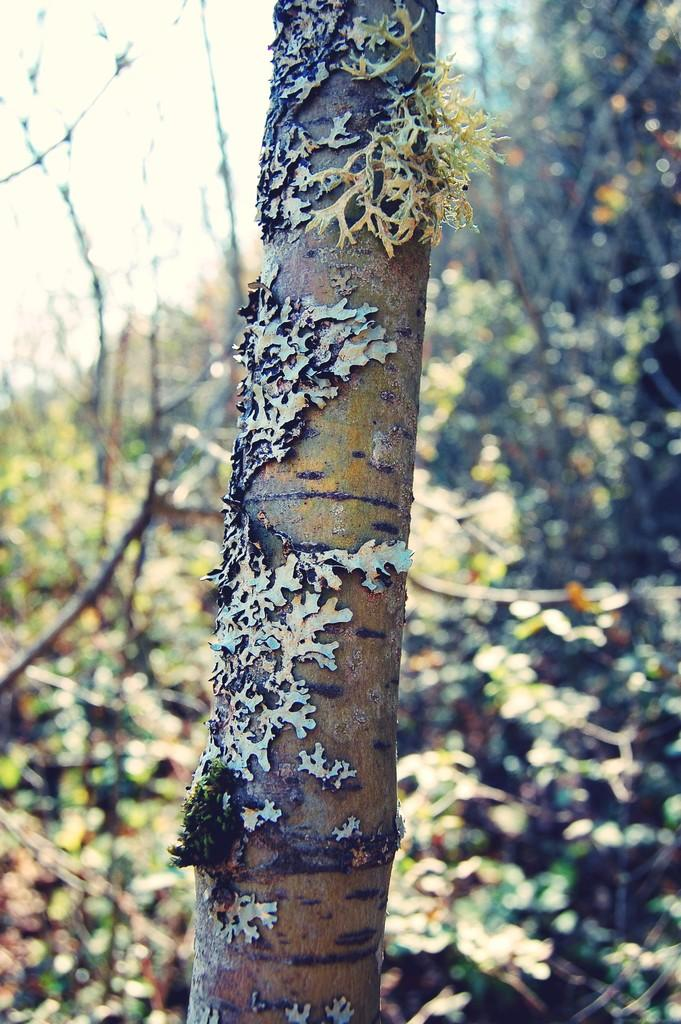What is the main subject of the image? The main subject of the image is the bark of a tree. Can you describe the background of the image? There are trees visible in the background of the image, and the sky is also visible. What type of skirt is hanging from the tree in the image? There is no skirt present in the image; it features the bark of a tree and the background includes trees and the sky. 